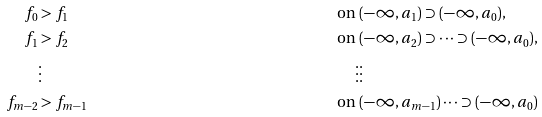Convert formula to latex. <formula><loc_0><loc_0><loc_500><loc_500>f _ { 0 } & > f _ { 1 } & \text { on } & ( - \infty , a _ { 1 } ) \supset ( - \infty , a _ { 0 } ) , \\ f _ { 1 } & > f _ { 2 } & \text { on } & ( - \infty , a _ { 2 } ) \supset \dots \supset ( - \infty , a _ { 0 } ) , \\ & \vdots & \vdots & \vdots \\ f _ { m - 2 } & > f _ { m - 1 } & \text { on } & ( - \infty , a _ { m - 1 } ) \dots \supset ( - \infty , a _ { 0 } )</formula> 